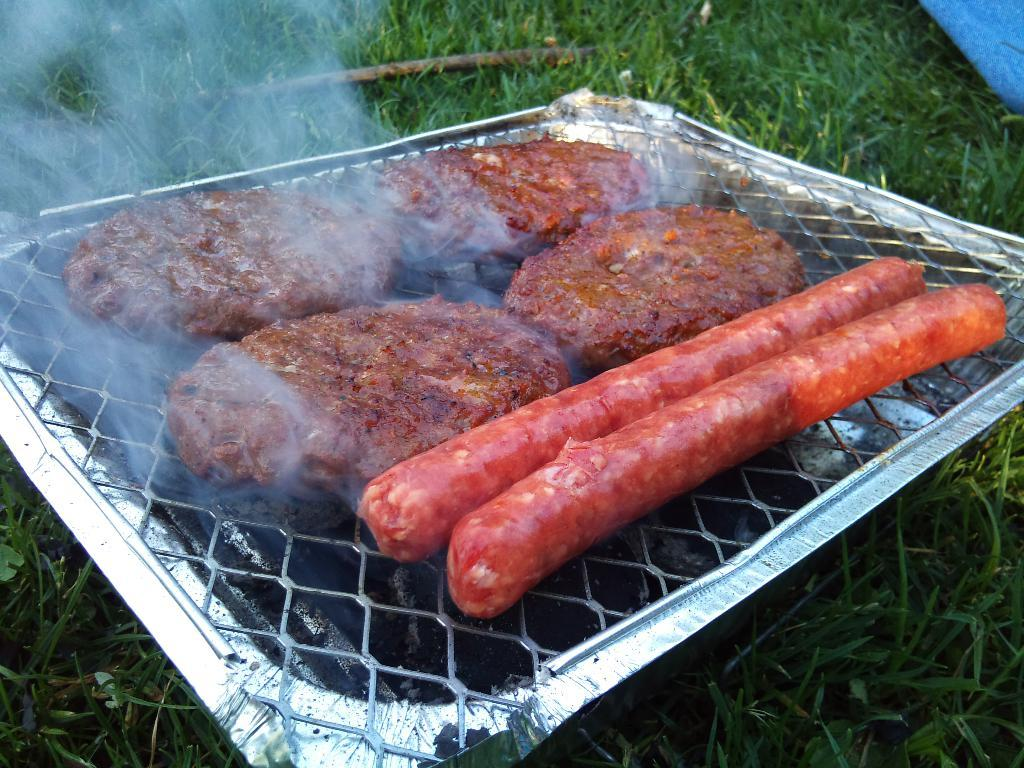What type of food is being cooked on the grill in the image? There are sausages and meat cutlets on the grill in the image. What can be seen coming from the grill? Smoke is visible in the image. What type of surface is visible in the image? There is grass visible in the image. What object can be seen in the image that is made of wood? There is a wooden stick in the image. What type of club is being used to hit the baseball in the image? There is no club or baseball present in the image; it features a grill with sausages and meat cutlets, smoke, grass, and a wooden stick. Can you tell me how many tents are set up in the image? There are no tents present in the image. 